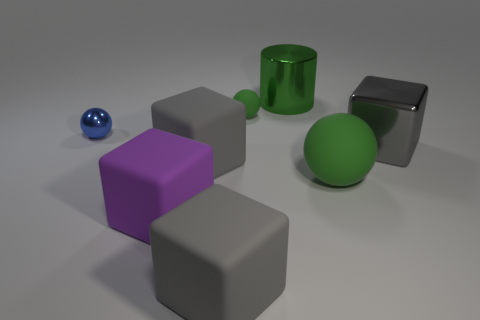Are there any large cyan blocks?
Your response must be concise. No. How many tiny things are either yellow rubber blocks or purple things?
Your answer should be compact. 0. Are there more blue objects that are in front of the big gray metallic block than big gray metal objects that are in front of the large rubber ball?
Your answer should be compact. No. Is the large ball made of the same material as the block that is to the right of the small green ball?
Ensure brevity in your answer.  No. The metallic ball has what color?
Your answer should be compact. Blue. There is a thing that is left of the large purple rubber thing; what shape is it?
Your answer should be very brief. Sphere. How many green objects are big metal objects or metallic balls?
Provide a succinct answer. 1. The cube that is the same material as the green cylinder is what color?
Offer a terse response. Gray. Is the color of the big shiny cylinder the same as the matte sphere that is behind the small metallic object?
Your response must be concise. Yes. What is the color of the shiny object that is in front of the big green metal thing and right of the large purple matte block?
Provide a short and direct response. Gray. 